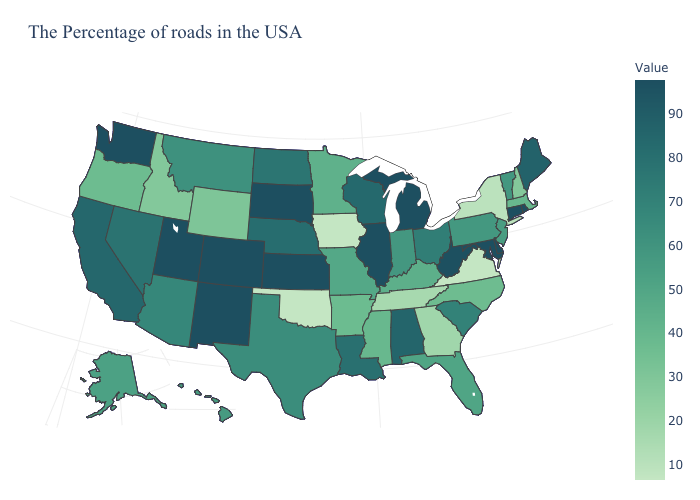Does California have a higher value than South Dakota?
Give a very brief answer. No. Does Maryland have the lowest value in the South?
Give a very brief answer. No. Which states have the highest value in the USA?
Write a very short answer. Rhode Island, Connecticut, Delaware, Maryland, Michigan, Illinois, Kansas, South Dakota, Colorado, New Mexico, Utah, Washington. Among the states that border Colorado , which have the highest value?
Keep it brief. Kansas, New Mexico, Utah. 